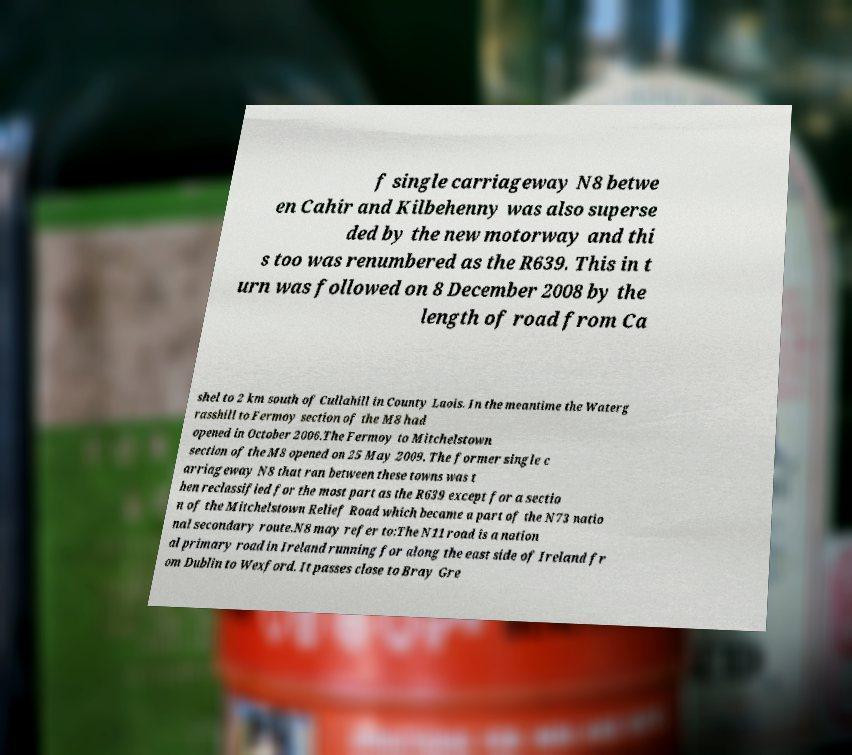For documentation purposes, I need the text within this image transcribed. Could you provide that? f single carriageway N8 betwe en Cahir and Kilbehenny was also superse ded by the new motorway and thi s too was renumbered as the R639. This in t urn was followed on 8 December 2008 by the length of road from Ca shel to 2 km south of Cullahill in County Laois. In the meantime the Waterg rasshill to Fermoy section of the M8 had opened in October 2006.The Fermoy to Mitchelstown section of the M8 opened on 25 May 2009. The former single c arriageway N8 that ran between these towns was t hen reclassified for the most part as the R639 except for a sectio n of the Mitchelstown Relief Road which became a part of the N73 natio nal secondary route.N8 may refer to:The N11 road is a nation al primary road in Ireland running for along the east side of Ireland fr om Dublin to Wexford. It passes close to Bray Gre 